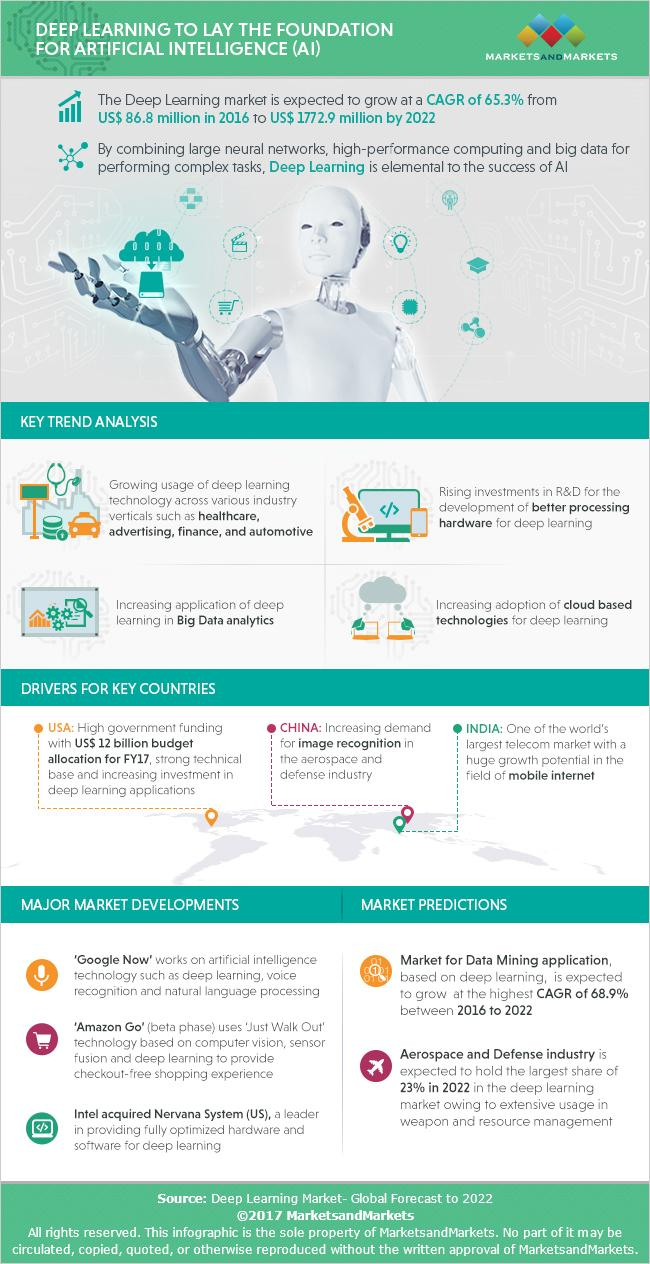List a handful of essential elements in this visual. The deep learning market has seen significant growth from 2016 to 2022, increasing by a total of 1,686.1 US dollars. 